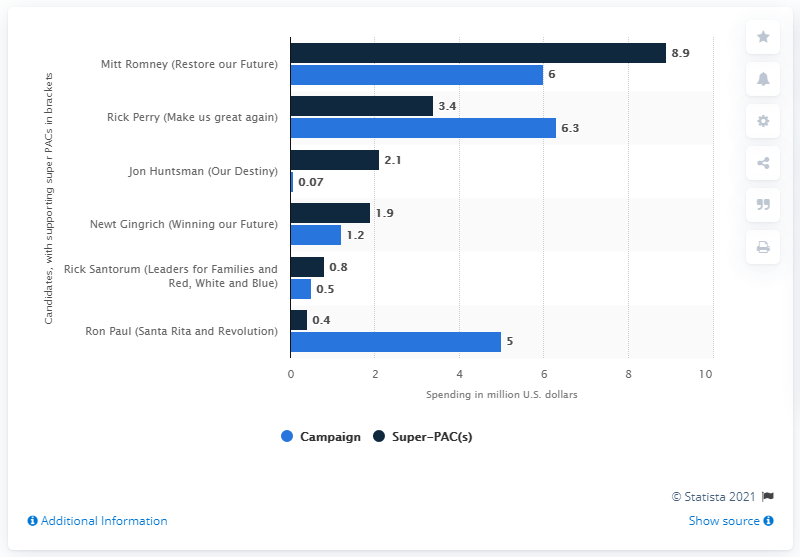Give some essential details in this illustration. The average of the first highest value and the third highest value in the blue bar is 5.65. The lowest value in the blue bar is 0.07. Restore our Future," a super PAC supporting Mitt Romney's presidential campaign, has spent a total of 8.9 dollars on advertising. 